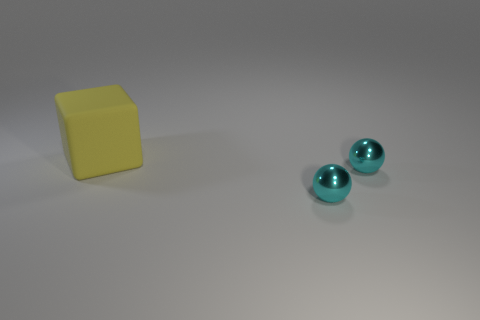Add 1 small balls. How many objects exist? 4 Subtract 0 cyan blocks. How many objects are left? 3 Subtract all spheres. How many objects are left? 1 Subtract all yellow balls. Subtract all yellow cylinders. How many balls are left? 2 Subtract all gray cubes. How many blue balls are left? 0 Subtract all big cubes. Subtract all tiny spheres. How many objects are left? 0 Add 2 yellow objects. How many yellow objects are left? 3 Add 1 cyan shiny balls. How many cyan shiny balls exist? 3 